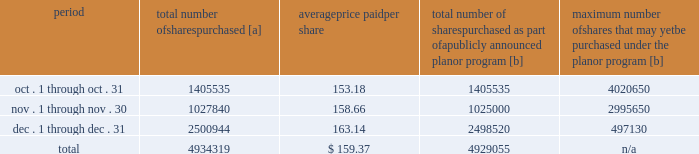Five-year performance comparison 2013 the following graph provides an indicator of cumulative total shareholder returns for the corporation as compared to the peer group index ( described above ) , the dj trans , and the s&p 500 .
The graph assumes that $ 100 was invested in the common stock of union pacific corporation and each index on december 31 , 2008 and that all dividends were reinvested .
The information below is historical in nature and is not necessarily indicative of future performance .
Purchases of equity securities 2013 during 2013 , we repurchased 14996957 shares of our common stock at an average price of $ 152.14 .
The table presents common stock repurchases during each month for the fourth quarter of 2013 : period total number of shares purchased [a] average price paid per share total number of shares purchased as part of a publicly announced plan or program [b] maximum number of shares that may yet be purchased under the plan or program [b] .
[a] total number of shares purchased during the quarter includes approximately 5264 shares delivered or attested to upc by employees to pay stock option exercise prices , satisfy excess tax withholding obligations for stock option exercises or vesting of retention units , and pay withholding obligations for vesting of retention shares .
[b] on april 1 , 2011 , our board of directors authorized the repurchase of up to 40 million shares of our common stock by march 31 , 2014 .
These repurchases may be made on the open market or through other transactions .
Our management has sole discretion with respect to determining the timing and amount of these transactions .
On november 21 , 2013 , the board of directors approved the early renewal of the share repurchase program , authorizing the repurchase of 60 million common shares by december 31 , 2017 .
The new authorization is effective january 1 , 2014 , and replaces the previous authorization , which expired on december 31 , 2013 , three months earlier than its original expiration date. .
For the quarter ended december 31 , 2013 what was the percent of the total number of shares purchased in november? 
Computations: (1027840 / 4934319)
Answer: 0.2083. 